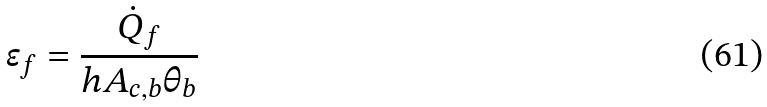<formula> <loc_0><loc_0><loc_500><loc_500>\epsilon _ { f } = \frac { \dot { Q } _ { f } } { h A _ { c , b } \theta _ { b } }</formula> 